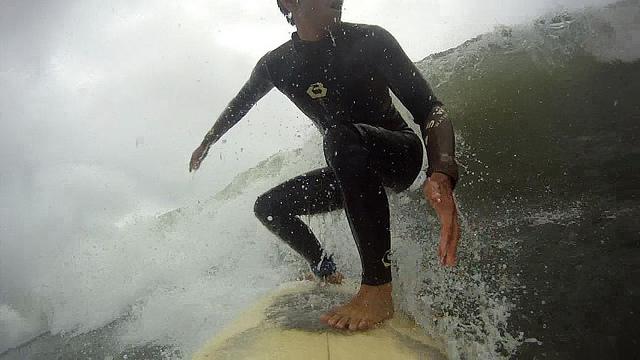What is this water sport called?
Quick response, please. Surfing. Is the man on top of a board?
Be succinct. Yes. What is the man wearing?
Write a very short answer. Wetsuit. 